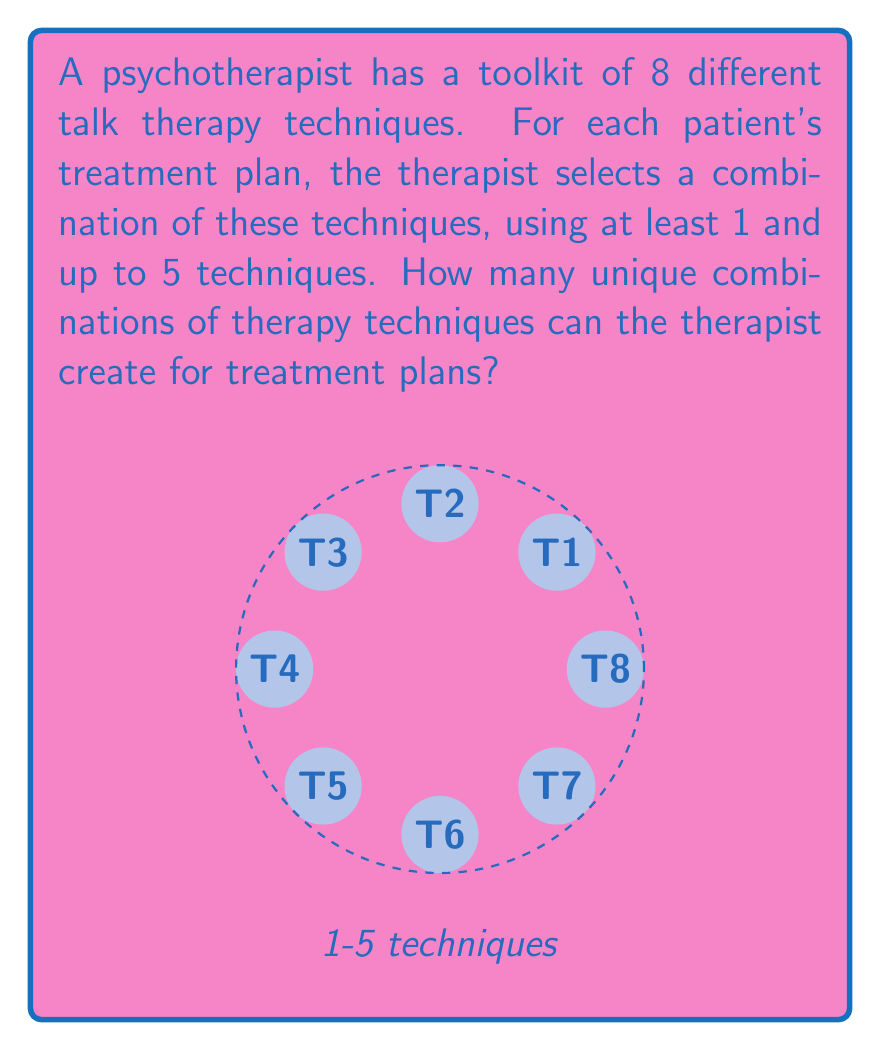Give your solution to this math problem. Let's approach this step-by-step:

1) We need to calculate the sum of combinations from choosing 1 up to 5 techniques out of 8.

2) The number of ways to choose $k$ items from $n$ items is given by the combination formula:

   $$\binom{n}{k} = \frac{n!}{k!(n-k)!}$$

3) We need to sum these combinations for $k$ from 1 to 5:

   $$\sum_{k=1}^{5} \binom{8}{k}$$

4) Let's calculate each term:

   $$\binom{8}{1} = 8$$
   $$\binom{8}{2} = 28$$
   $$\binom{8}{3} = 56$$
   $$\binom{8}{4} = 70$$
   $$\binom{8}{5} = 56$$

5) Now, we sum these values:

   $$8 + 28 + 56 + 70 + 56 = 218$$

Therefore, the therapist can create 218 unique combinations of therapy techniques for treatment plans.
Answer: 218 